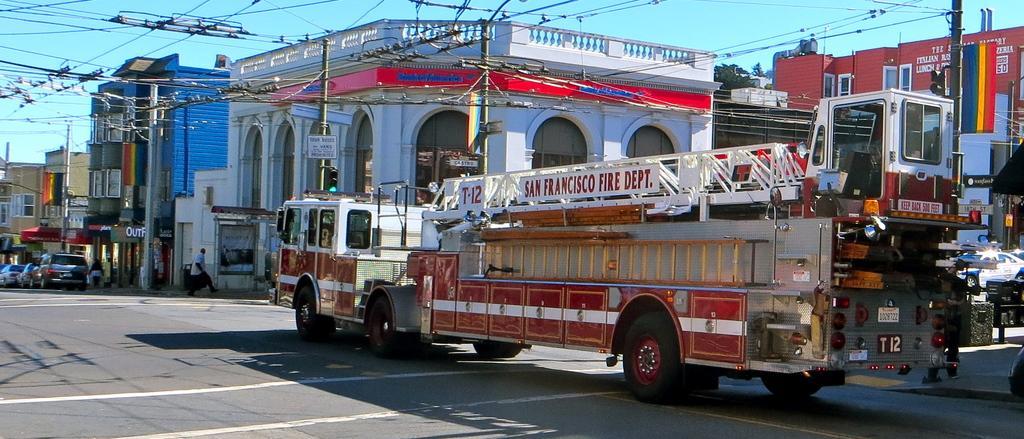How would you summarize this image in a sentence or two? In this image we can see there is a road. On the road they are many vehicles parked and some utility poles connected with cables. In the background of the image there are buildings, trees and sky. 